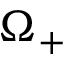Convert formula to latex. <formula><loc_0><loc_0><loc_500><loc_500>\Omega _ { + }</formula> 